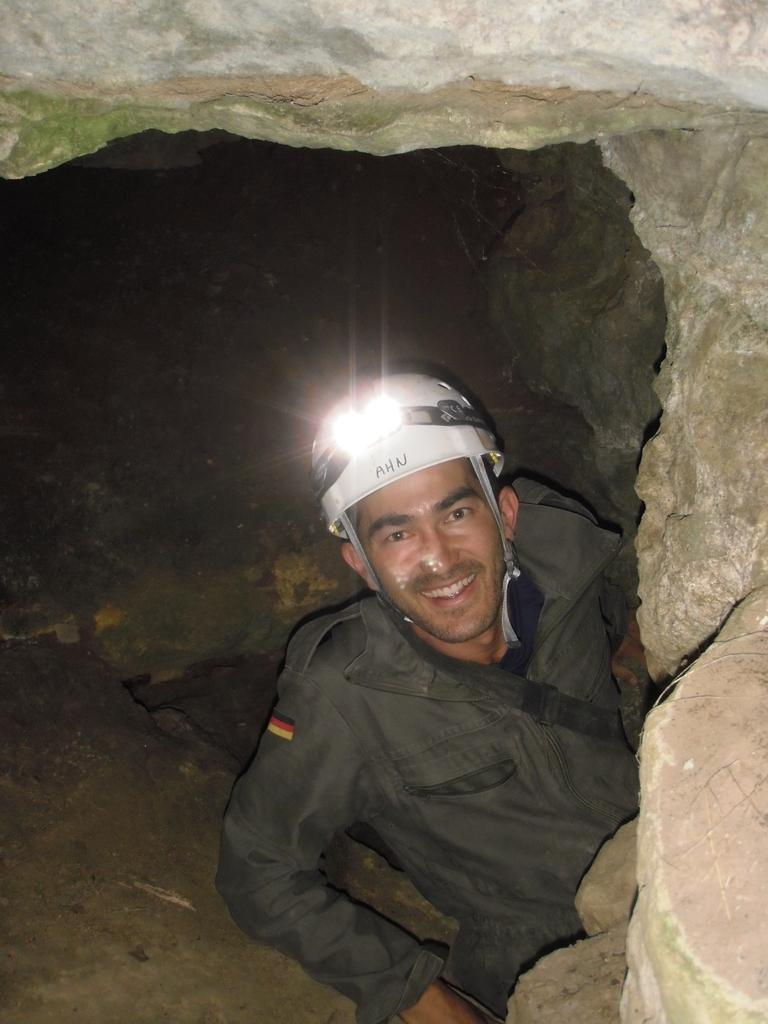What is the main feature of the image? There is a cave in the image. Is there anyone inside the cave? Yes, a person is sitting in the cave. How is the person feeling? The person is smiling. Where is the kitten positioned in the image? There is no kitten present in the image. What type of bee can be seen buzzing around the person in the cave? There are no bees present in the image. 